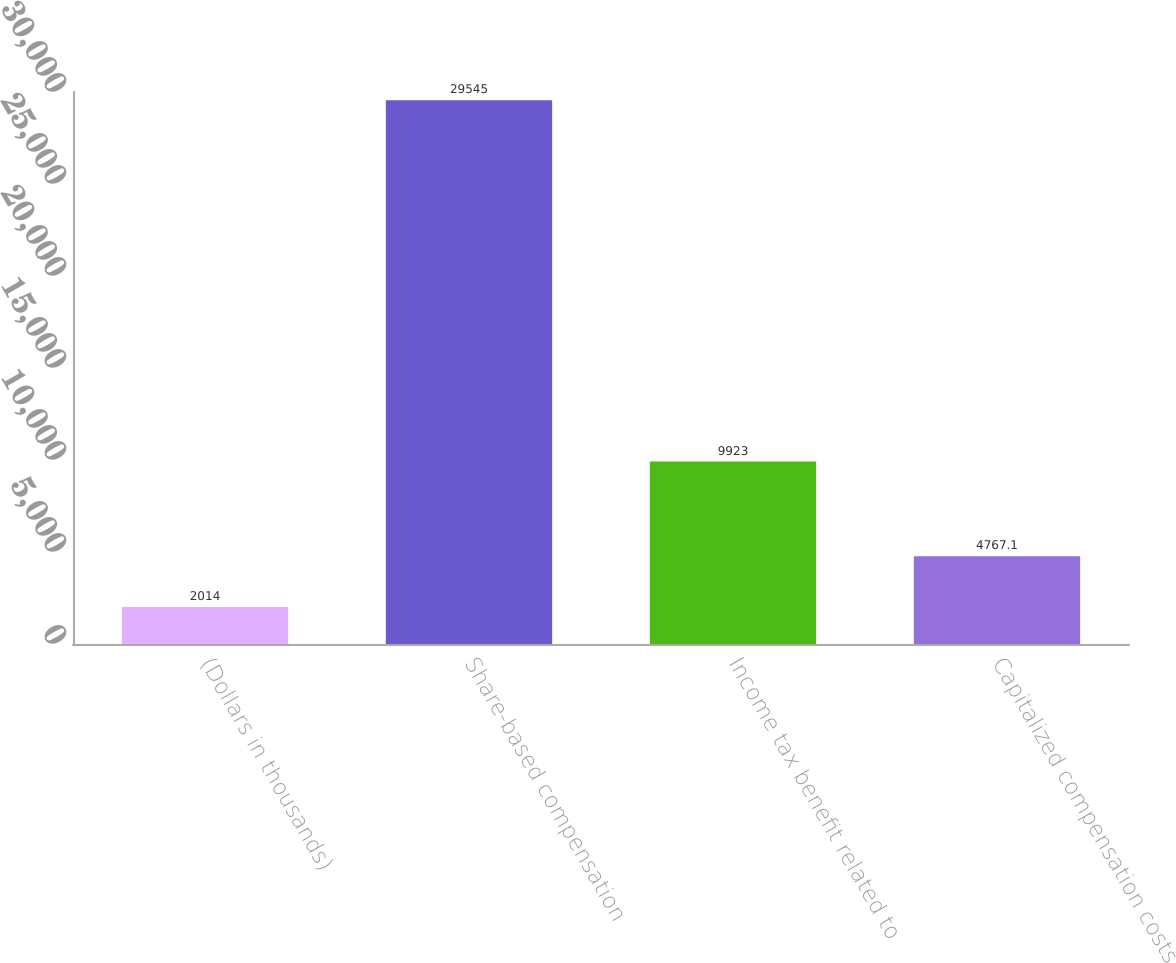<chart> <loc_0><loc_0><loc_500><loc_500><bar_chart><fcel>(Dollars in thousands)<fcel>Share-based compensation<fcel>Income tax benefit related to<fcel>Capitalized compensation costs<nl><fcel>2014<fcel>29545<fcel>9923<fcel>4767.1<nl></chart> 